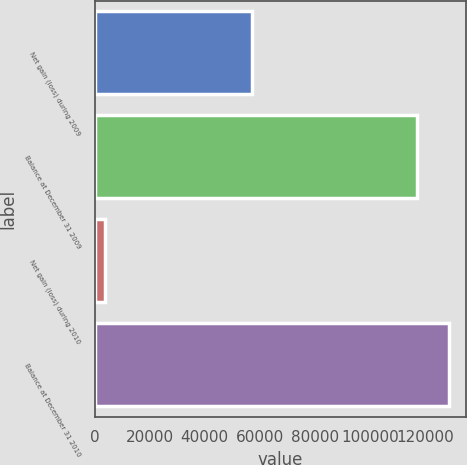Convert chart to OTSL. <chart><loc_0><loc_0><loc_500><loc_500><bar_chart><fcel>Net gain (loss) during 2009<fcel>Balance at December 31 2009<fcel>Net gain (loss) during 2010<fcel>Balance at December 31 2010<nl><fcel>57284<fcel>117046<fcel>3846<fcel>128751<nl></chart> 